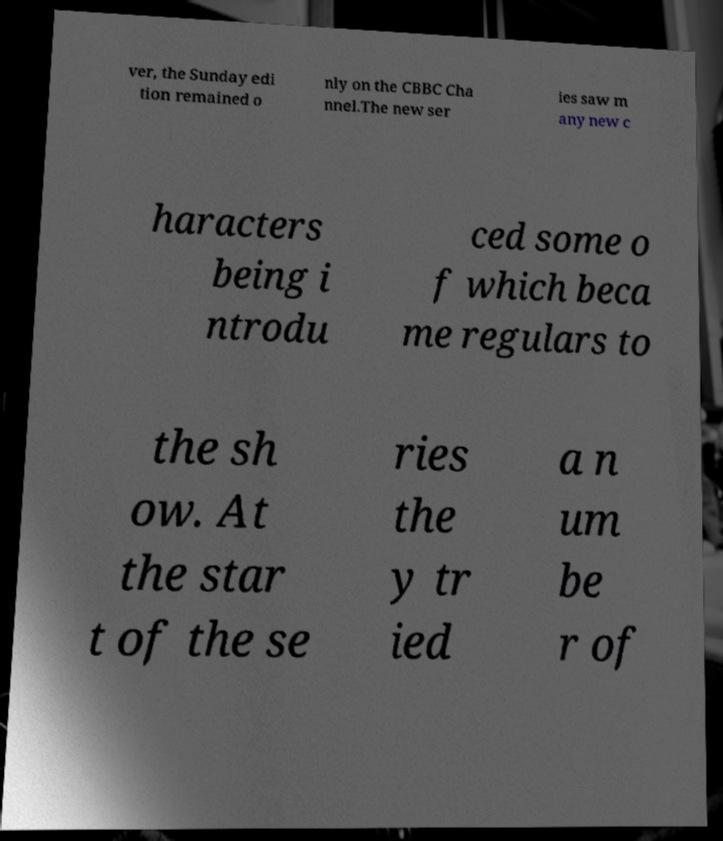For documentation purposes, I need the text within this image transcribed. Could you provide that? ver, the Sunday edi tion remained o nly on the CBBC Cha nnel.The new ser ies saw m any new c haracters being i ntrodu ced some o f which beca me regulars to the sh ow. At the star t of the se ries the y tr ied a n um be r of 